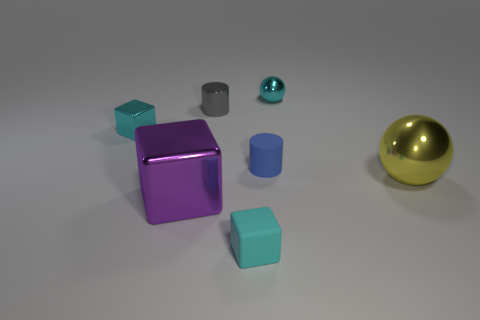Do the tiny block in front of the big purple shiny block and the small cyan ball that is left of the yellow metallic sphere have the same material?
Ensure brevity in your answer.  No. What number of things are either small gray shiny objects or cyan objects behind the large sphere?
Give a very brief answer. 3. Are there any other things that are the same material as the blue cylinder?
Provide a succinct answer. Yes. What is the shape of the small matte thing that is the same color as the tiny shiny block?
Give a very brief answer. Cube. What is the material of the blue thing?
Your answer should be compact. Rubber. Do the gray thing and the small sphere have the same material?
Offer a very short reply. Yes. How many rubber objects are big spheres or big yellow cubes?
Provide a short and direct response. 0. What is the shape of the large thing that is right of the big purple cube?
Make the answer very short. Sphere. There is another ball that is made of the same material as the big yellow sphere; what size is it?
Provide a succinct answer. Small. There is a cyan thing that is both behind the big block and to the right of the small gray thing; what shape is it?
Your answer should be compact. Sphere. 